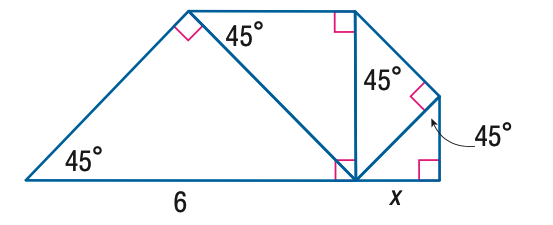Answer the mathemtical geometry problem and directly provide the correct option letter.
Question: Each triangle in the figure is a 45 - 45 - 90 triangle. Find x.
Choices: A: \frac { 3 } { 2 } B: \frac { 3 } { 2 } \sqrt { 2 } C: 3 D: 3 \sqrt { 2 } A 